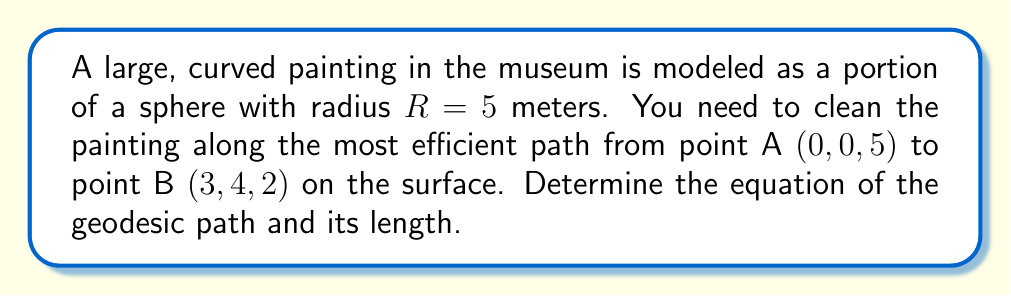Give your solution to this math problem. To solve this problem, we'll follow these steps:

1) First, we need to recognize that on a sphere, the geodesic path is a great circle. The equation of a great circle can be found by intersecting the sphere with a plane passing through the center of the sphere and the two points.

2) The equation of the sphere is:
   $$ x^2 + y^2 + z^2 = R^2 = 25 $$

3) The plane passing through the center (0,0,0) and points A and B has the normal vector $\vec{n} = \vec{OA} \times \vec{OB}$. Let's calculate this:

   $\vec{OA} = (0, 0, 5)$
   $\vec{OB} = (3, 4, 2)$
   
   $\vec{n} = (0, 0, 5) \times (3, 4, 2) = (-20, 15, 0)$

4) The equation of the plane is thus:
   $$ -20x + 15y + 0z = 0 $$
   Simplifying: $4x - 3y = 0$

5) The geodesic path is the intersection of this plane with the sphere. We can parameterize this path using spherical coordinates:

   $x = R \sin\theta \cos\phi$
   $y = R \sin\theta \sin\phi$
   $z = R \cos\theta$

   Where $\theta$ is the polar angle and $\phi$ is the azimuthal angle.

6) Substituting these into the plane equation:
   $4R \sin\theta \cos\phi - 3R \sin\theta \sin\phi = 0$
   $\tan\phi = \frac{4}{3}$

7) This gives us the equation of the geodesic path:
   $$ x = 5 \sin\theta \cdot \frac{3}{\sqrt{25}}, y = 5 \sin\theta \cdot \frac{4}{\sqrt{25}}, z = 5 \cos\theta $$
   Where $\theta$ varies from $\arccos(1) = 0$ to $\arccos(\frac{2}{5}) \approx 1.369$.

8) The length of this geodesic path is given by the arc length formula:
   $$ s = R \cdot \arccos(\frac{\vec{OA} \cdot \vec{OB}}{R^2}) $$
   $$ s = 5 \cdot \arccos(\frac{0 \cdot 3 + 0 \cdot 4 + 5 \cdot 2}{5^2}) = 5 \arccos(\frac{2}{5}) \approx 6.845 \text{ meters} $$
Answer: Geodesic equation: $x = \frac{3}{\sqrt{25}} \cdot 5\sin\theta$, $y = \frac{4}{\sqrt{25}} \cdot 5\sin\theta$, $z = 5\cos\theta$; Length: $5 \arccos(\frac{2}{5}) \approx 6.845$ m 